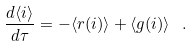Convert formula to latex. <formula><loc_0><loc_0><loc_500><loc_500>\frac { d \langle i \rangle } { d \tau } = - \langle r ( i ) \rangle + \langle g ( i ) \rangle \ .</formula> 